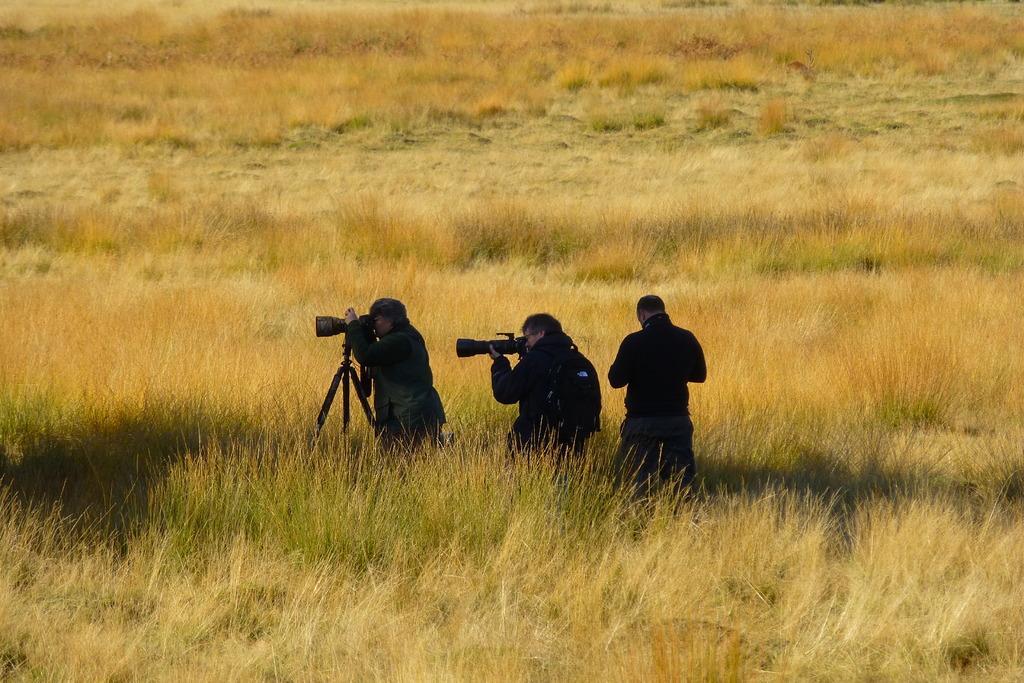Can you describe this image briefly? In this image there are three people holding cameras in the grass and there is a camera stand. 